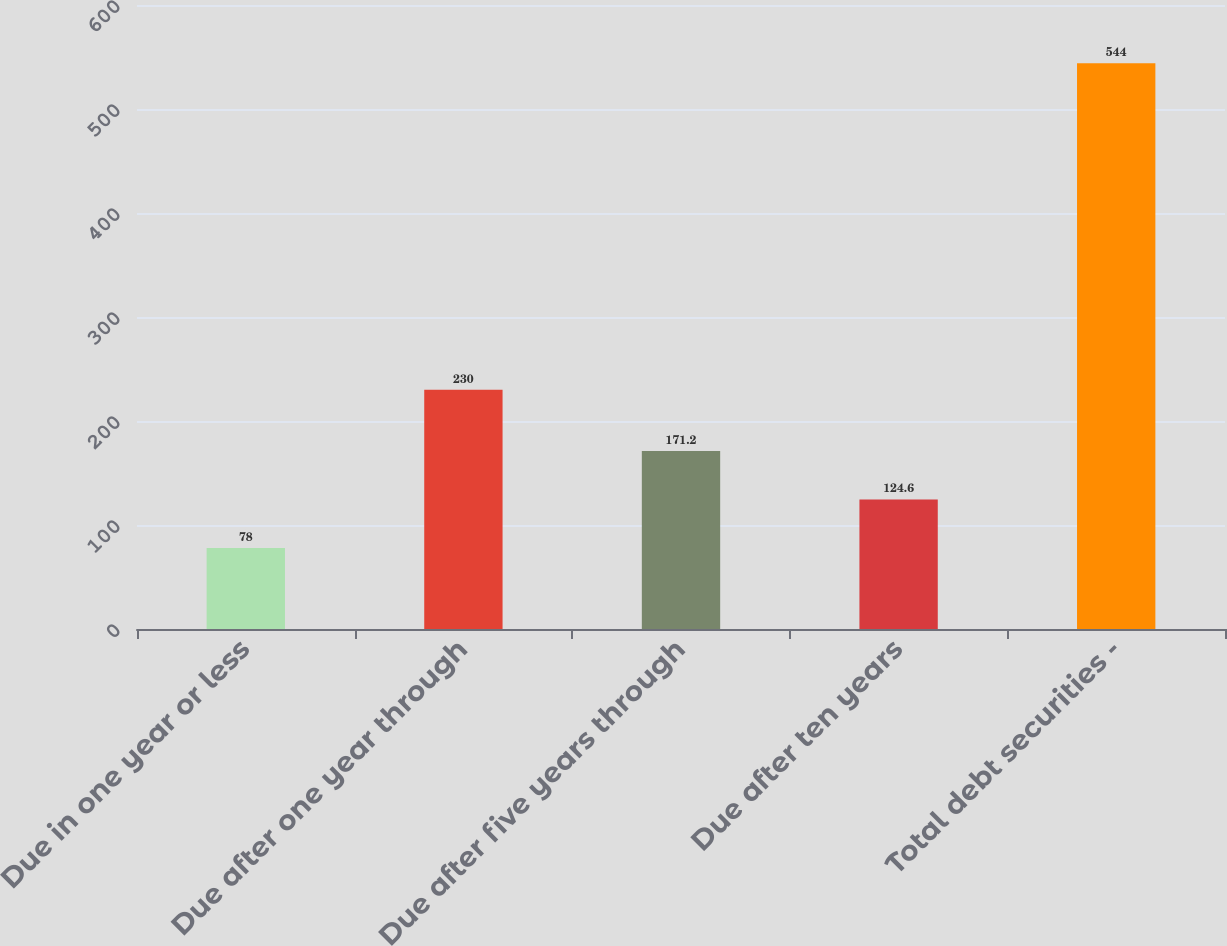<chart> <loc_0><loc_0><loc_500><loc_500><bar_chart><fcel>Due in one year or less<fcel>Due after one year through<fcel>Due after five years through<fcel>Due after ten years<fcel>Total debt securities -<nl><fcel>78<fcel>230<fcel>171.2<fcel>124.6<fcel>544<nl></chart> 